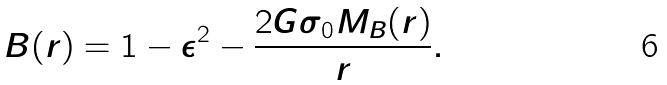Convert formula to latex. <formula><loc_0><loc_0><loc_500><loc_500>B ( r ) = 1 - \epsilon ^ { 2 } - \frac { 2 G \sigma _ { 0 } M _ { B } ( r ) } { r } .</formula> 